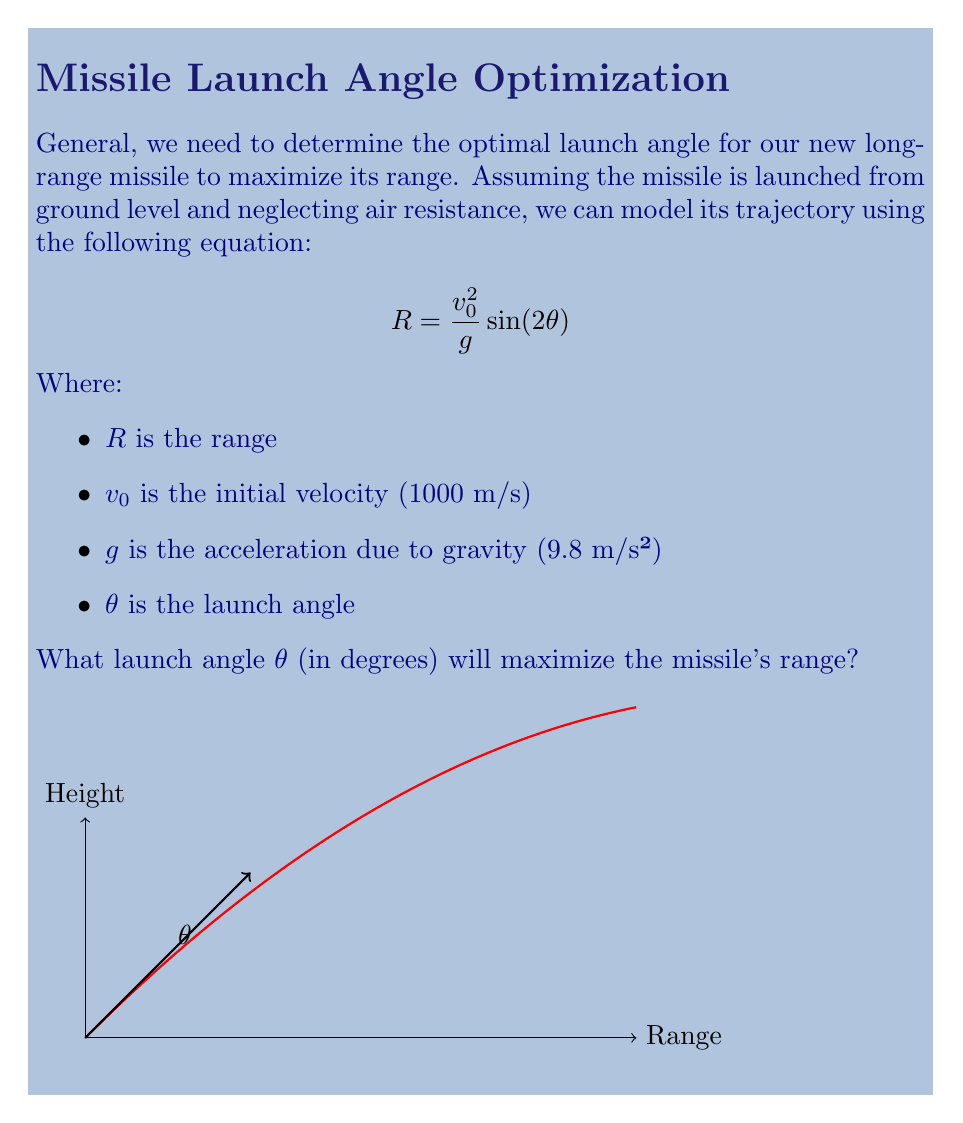What is the answer to this math problem? Let's approach this step-by-step:

1) The range $R$ is a function of $\theta$. To find the maximum range, we need to find the value of $\theta$ that maximizes this function.

2) In calculus, we know that the maximum of a function occurs where its derivative equals zero. So, let's differentiate $R$ with respect to $\theta$:

   $$\frac{dR}{d\theta} = \frac{v_0^2}{g} \cdot 2\cos(2\theta)$$

3) Set this derivative to zero and solve for $\theta$:

   $$\frac{v_0^2}{g} \cdot 2\cos(2\theta) = 0$$

   $$\cos(2\theta) = 0$$

4) The cosine function equals zero when its argument is $\frac{\pi}{2}$ or $\frac{3\pi}{2}$ radians. In this case:

   $$2\theta = \frac{\pi}{2}$$

   $$\theta = \frac{\pi}{4} \text{ radians}$$

5) Convert radians to degrees:

   $$\theta = \frac{\pi}{4} \cdot \frac{180°}{\pi} = 45°$$

Therefore, the optimal launch angle to maximize the missile's range is 45°. This result is independent of the initial velocity and gravitational acceleration, making it a universal principle for projectile motion in a vacuum.
Answer: 45° 